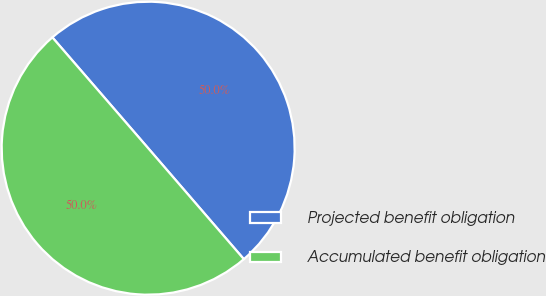Convert chart. <chart><loc_0><loc_0><loc_500><loc_500><pie_chart><fcel>Projected benefit obligation<fcel>Accumulated benefit obligation<nl><fcel>50.02%<fcel>49.98%<nl></chart> 